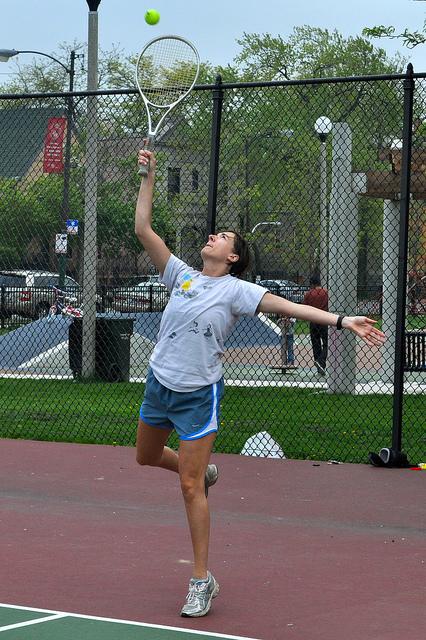Is she reaching downwards?
Answer briefly. No. Does the person have her eye on the ball?
Keep it brief. Yes. What is on the woman's wrist?
Be succinct. Watch. 